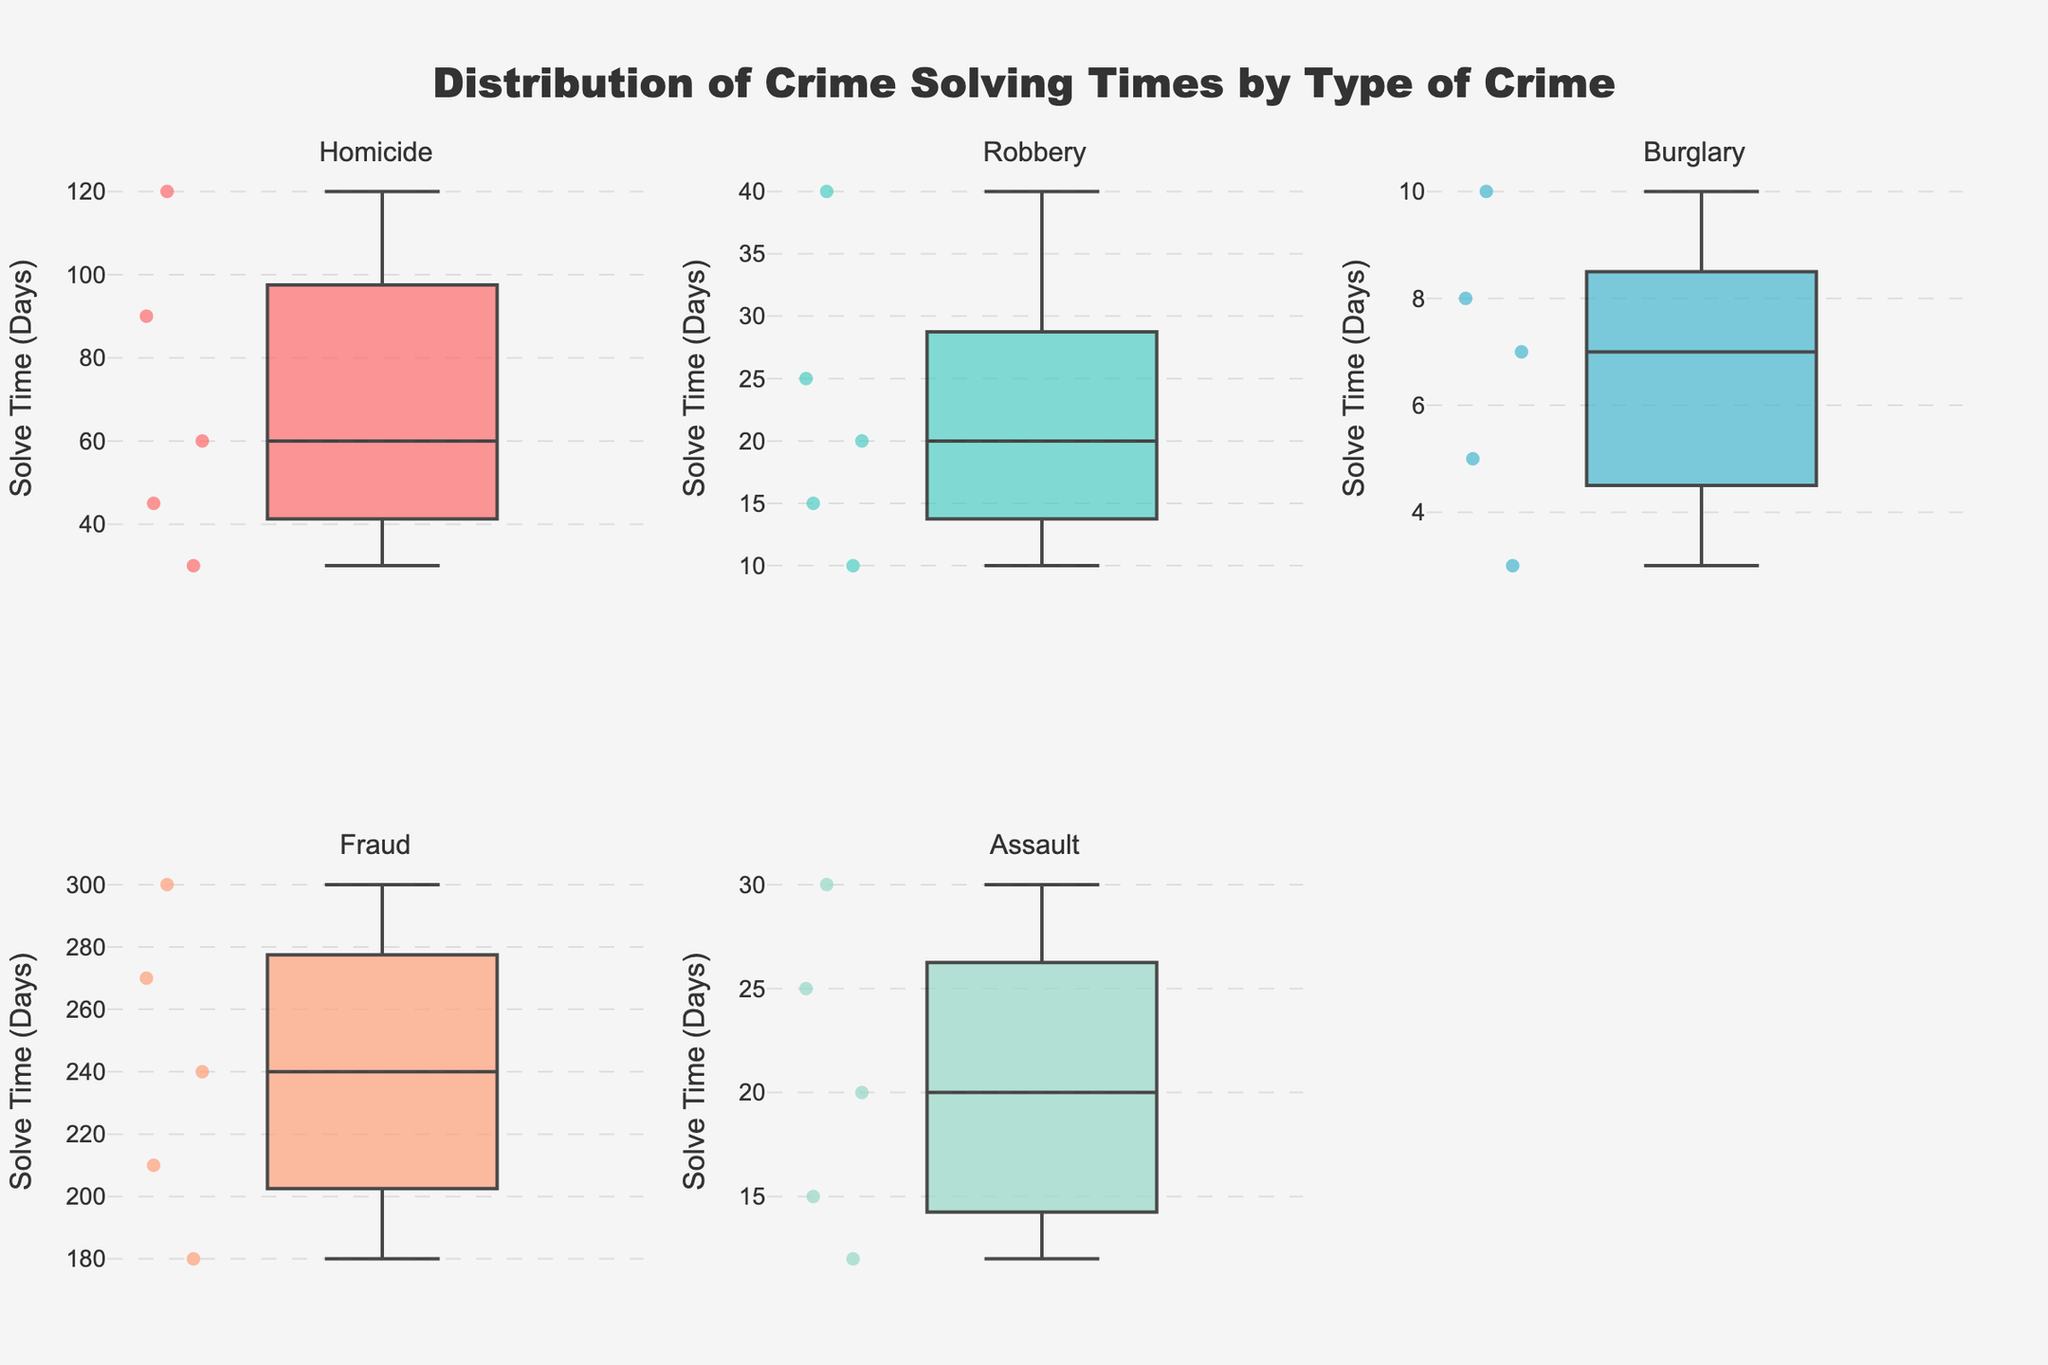What is the title of the figure? The title of the figure is usually positioned at the top center of the plot. In this case, it's stated in the 'update_layout' section specifying the title text.
Answer: Distribution of Crime Solving Times by Type of Crime How many subplots are there in the figure? The subplots are created in a 2x3 grid in the 'make_subplots' section. Counting all the positions, we get 6 subplots.
Answer: 6 Which crime type has the highest median solve time? The median can be inferred from the central line of the box plot. 'Fraud' has a noticeable high median compare to other crime types.
Answer: Fraud What is the range of solve times for Homicide cases? The range of a box plot is determined by the minimum and maximum points excluding outliers. For Homicide, the minimum is 30 days and the maximum is 120 days.
Answer: 30-120 days Which crime type has the smallest interquartile range (IQR)? The IQR is the range between the first quartile (Q1) and the third quartile (Q3). 'Burglary' appears to have the smallest box, implying the smallest IQR.
Answer: Burglary Which crime type has the most outliers? Outliers are points outside the whiskers of a box plot. 'Fraud' will likely have the most visible points outside its whiskers.
Answer: Fraud Are the solve times of Burglary cases more consistent than those of other crime types? Consistency can be evaluated by the IQR and overall spread of the box plot. 'Burglary' has a very compact box plot, suggesting fewer variations in solve times.
Answer: Yes Which crime type has a median solve time greater than 200 days? The median of 'Fraud' is greater than 200 days, as indicated by the central line of its box plot.
Answer: Fraud What is the range of solve times for Robbery cases? For robbery cases, the range is from about 10 days to 40 days when inspecting the minimum and maximum points of the plot.
Answer: 10-40 days 